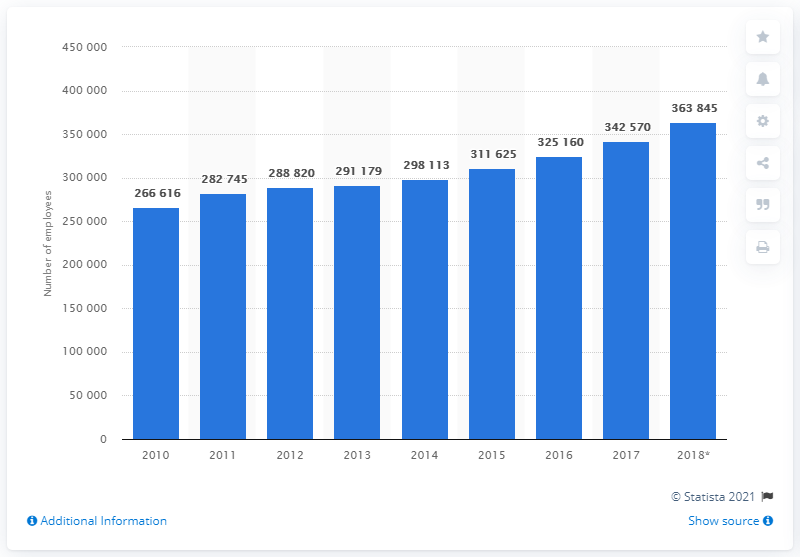Specify some key components in this picture. In 2018, there were approximately 363,845 people employed in the Swedish construction industry. 